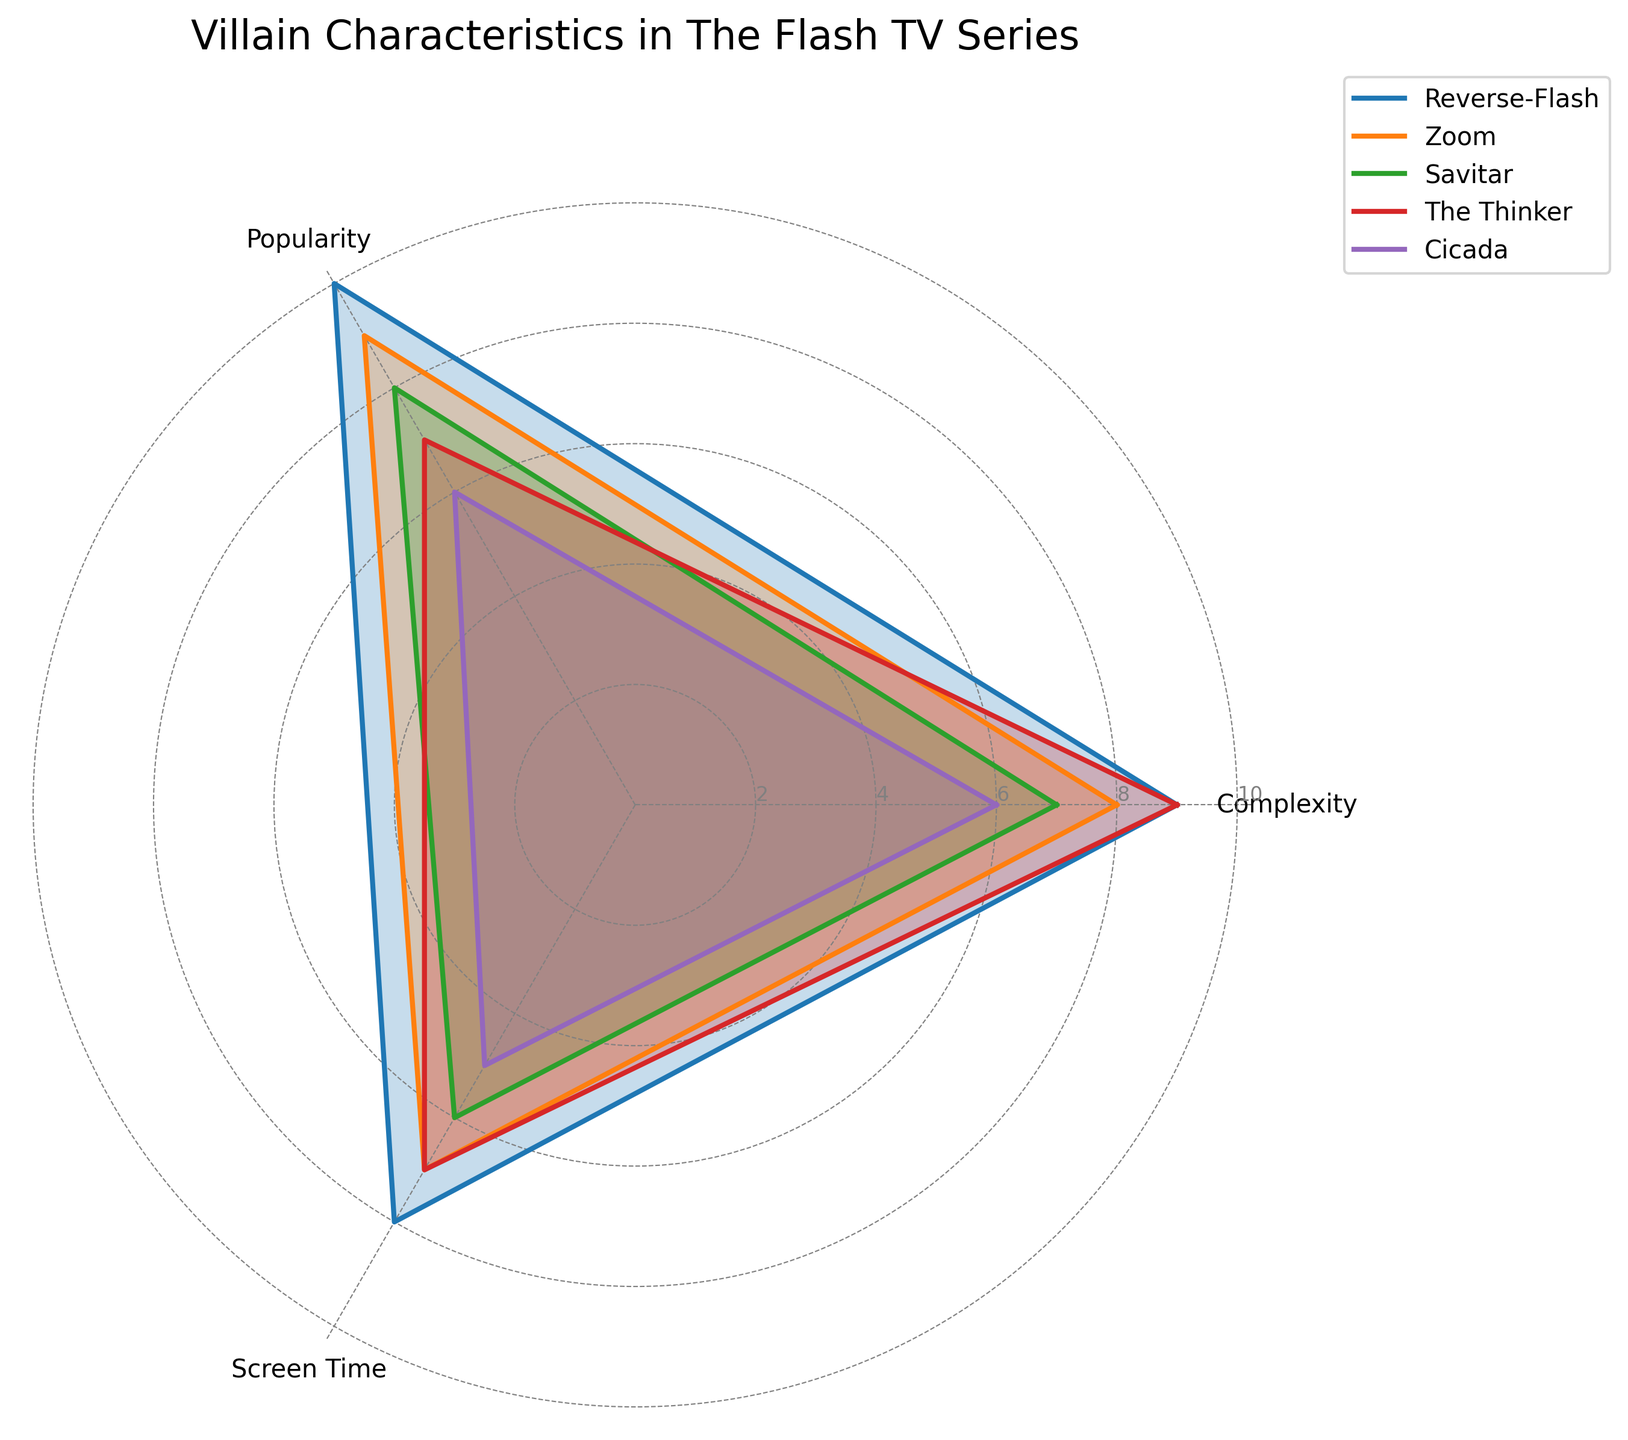How many villains are represented in the figure? The figure shows four groups representing the villains: Reverse-Flash, Zoom, Savitar, The Thinker, and Cicada.
Answer: 5 Which category has the highest score for Reverse-Flash? From the plot, for Reverse-Flash, the highest score among Complexity, Popularity, and Screen Time is in Popularity.
Answer: Popularity What is the difference in Complexity scores between Zoom and Cicada? Looking at the figure, Zoom has a Complexity score of 8, and Cicada has a score of 6. The difference is 8 - 6 = 2.
Answer: 2 Which villain has the highest Screen Time score? By examining the values in the radar chart, Reverse-Flash has the highest Screen Time score with a value of 8.
Answer: Reverse-Flash Does any villain have equal scores for all three categories? To determine this, we compare the Complexity, Popularity, and Screen Time scores for each villain. None of the villains have equal scores across all categories.
Answer: No Which villain's score distribution has a symmetric appearance on the radar chart? The symmetric appearance on a radar chart can be seen in The Thinker, who has fairly balanced scores: Complexity (9), Popularity (7), and Screen Time (7).
Answer: The Thinker What is the average Complexity score of all villains? The Complexity scores for the villains are 9, 8, 7, 9, and 6. Their sum is 9+8+7+9+6 = 39. There are 5 villains, so the average is 39/5 = 7.8.
Answer: 7.8 In which categories does Savitar have higher scores than Cicada? The scores for Savitar (Complexity: 7, Popularity: 8, Screen Time: 6) are compared to Cicada (Complexity: 6, Popularity: 6, Screen Time: 5). Savitar has higher scores in all categories: Complexity, Popularity, and Screen Time.
Answer: All categories What are the median Popularity scores of the villains? The Popularity scores are 10, 9, 8, 7, and 6. When sorted, they are 6, 7, 8, 9, and 10. The median value is 8.
Answer: 8 Considering Complexity and Screen Time, which villain consistently scores high (7 and above) in both categories? Evaluating the scores for both Complexity and Screen Time, we find Reverse-Flash (9, 8), Zoom (8, 7), and The Thinker (9, 7) have scores 7 and above in both categories.
Answer: Reverse-Flash, Zoom, The Thinker 